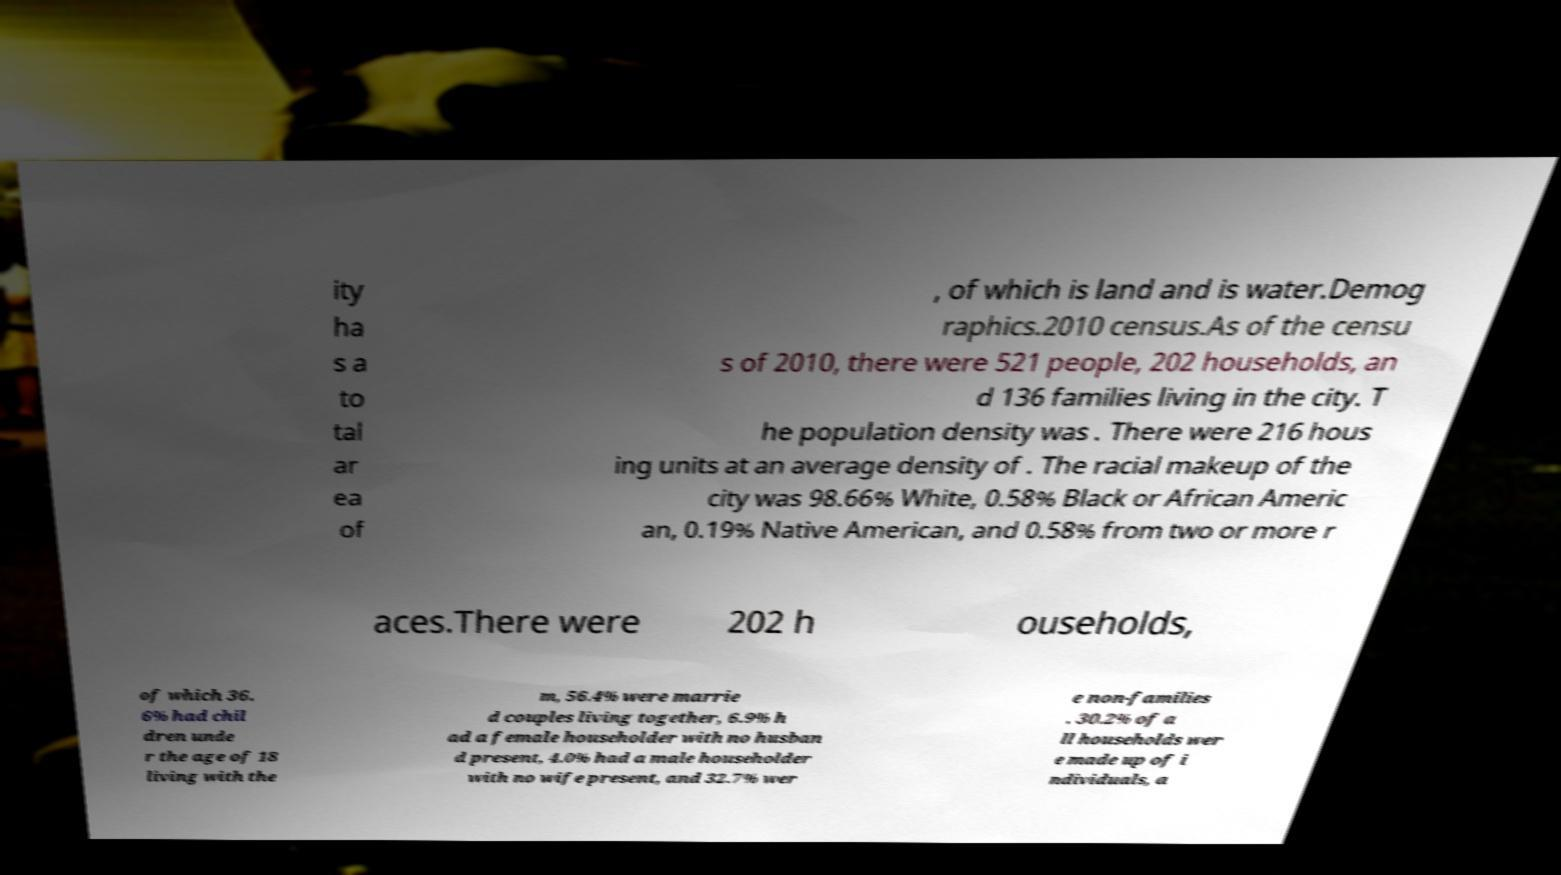Please read and relay the text visible in this image. What does it say? ity ha s a to tal ar ea of , of which is land and is water.Demog raphics.2010 census.As of the censu s of 2010, there were 521 people, 202 households, an d 136 families living in the city. T he population density was . There were 216 hous ing units at an average density of . The racial makeup of the city was 98.66% White, 0.58% Black or African Americ an, 0.19% Native American, and 0.58% from two or more r aces.There were 202 h ouseholds, of which 36. 6% had chil dren unde r the age of 18 living with the m, 56.4% were marrie d couples living together, 6.9% h ad a female householder with no husban d present, 4.0% had a male householder with no wife present, and 32.7% wer e non-families . 30.2% of a ll households wer e made up of i ndividuals, a 